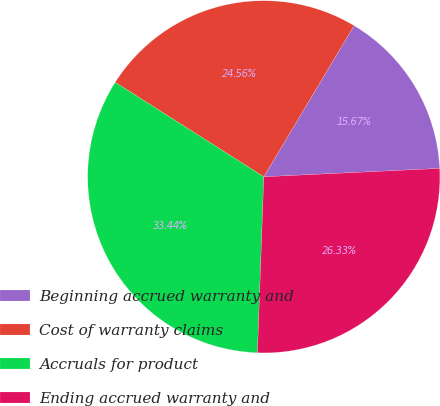Convert chart. <chart><loc_0><loc_0><loc_500><loc_500><pie_chart><fcel>Beginning accrued warranty and<fcel>Cost of warranty claims<fcel>Accruals for product<fcel>Ending accrued warranty and<nl><fcel>15.67%<fcel>24.56%<fcel>33.44%<fcel>26.33%<nl></chart> 